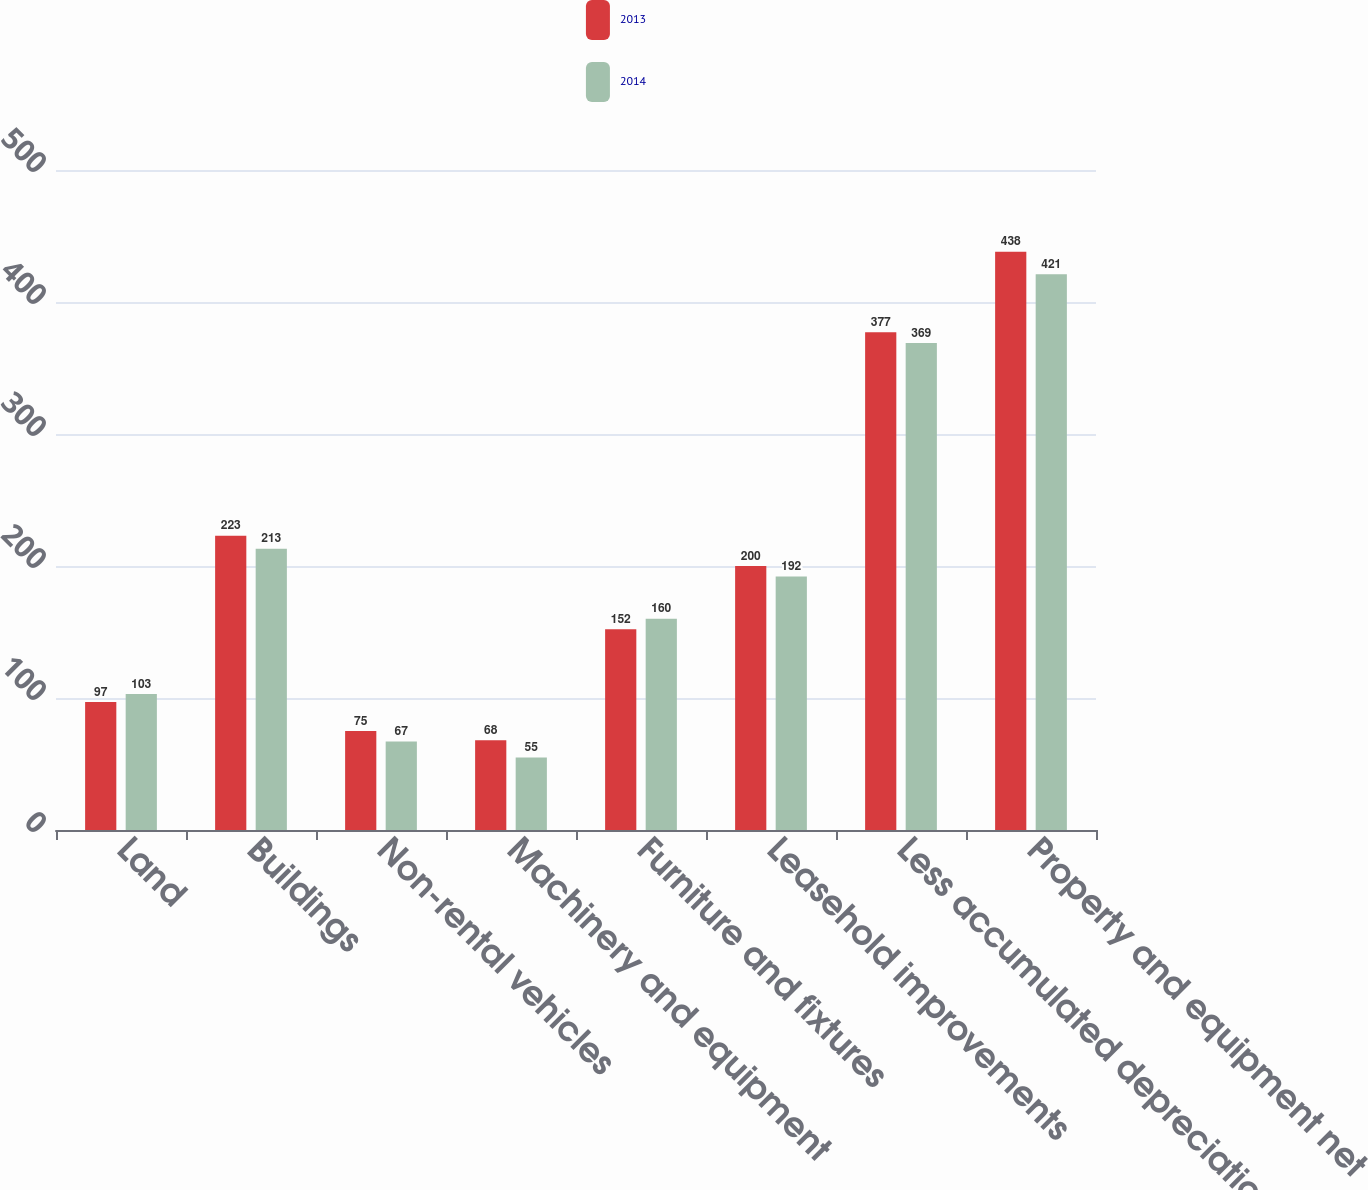<chart> <loc_0><loc_0><loc_500><loc_500><stacked_bar_chart><ecel><fcel>Land<fcel>Buildings<fcel>Non-rental vehicles<fcel>Machinery and equipment<fcel>Furniture and fixtures<fcel>Leasehold improvements<fcel>Less accumulated depreciation<fcel>Property and equipment net<nl><fcel>2013<fcel>97<fcel>223<fcel>75<fcel>68<fcel>152<fcel>200<fcel>377<fcel>438<nl><fcel>2014<fcel>103<fcel>213<fcel>67<fcel>55<fcel>160<fcel>192<fcel>369<fcel>421<nl></chart> 